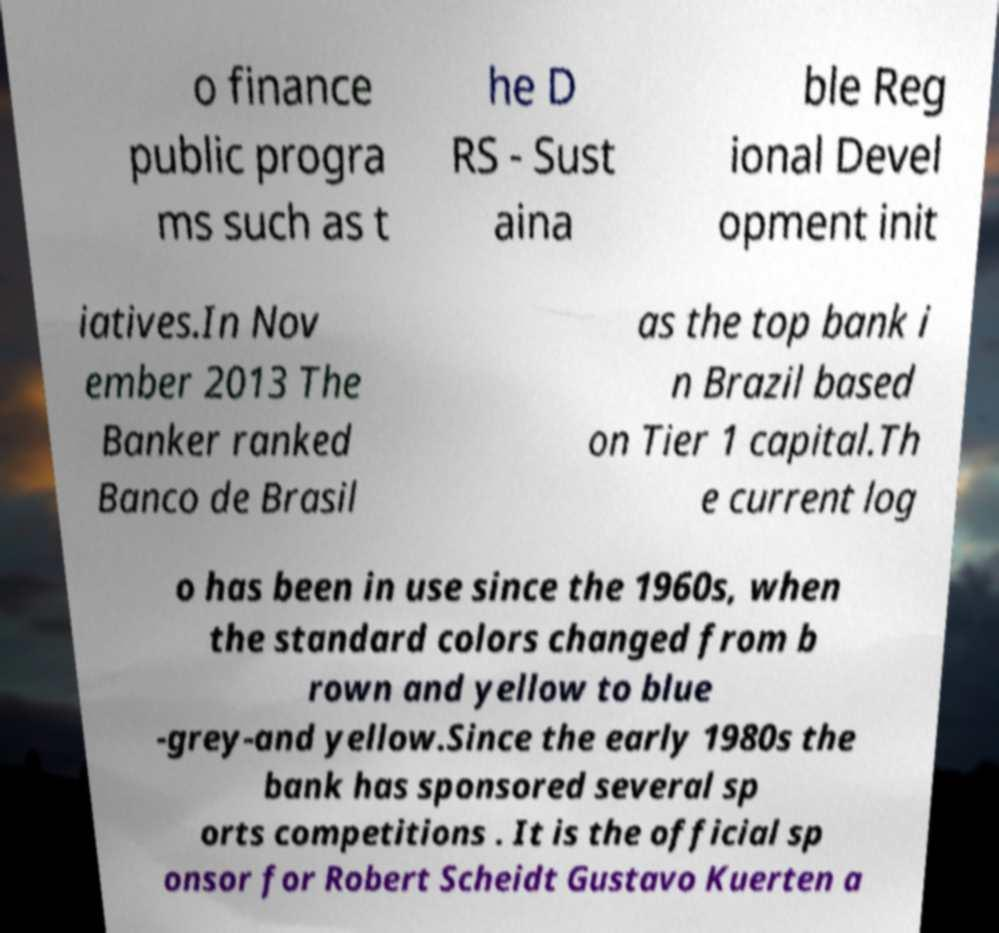There's text embedded in this image that I need extracted. Can you transcribe it verbatim? o finance public progra ms such as t he D RS - Sust aina ble Reg ional Devel opment init iatives.In Nov ember 2013 The Banker ranked Banco de Brasil as the top bank i n Brazil based on Tier 1 capital.Th e current log o has been in use since the 1960s, when the standard colors changed from b rown and yellow to blue -grey-and yellow.Since the early 1980s the bank has sponsored several sp orts competitions . It is the official sp onsor for Robert Scheidt Gustavo Kuerten a 